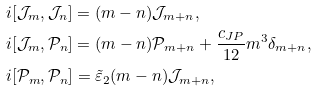<formula> <loc_0><loc_0><loc_500><loc_500>& i [ \mathcal { J } _ { m } , \mathcal { J } _ { n } ] = ( m - n ) \mathcal { J } _ { m + n } , \\ & i [ \mathcal { J } _ { m } , \mathcal { P } _ { n } ] = ( m - n ) \mathcal { P } _ { m + n } + \frac { c _ { J P } } { 1 2 } m ^ { 3 } \delta _ { m + n } , \\ & i [ \mathcal { P } _ { m } , \mathcal { P } _ { n } ] = \tilde { \varepsilon } _ { 2 } ( m - n ) \mathcal { J } _ { m + n } ,</formula> 